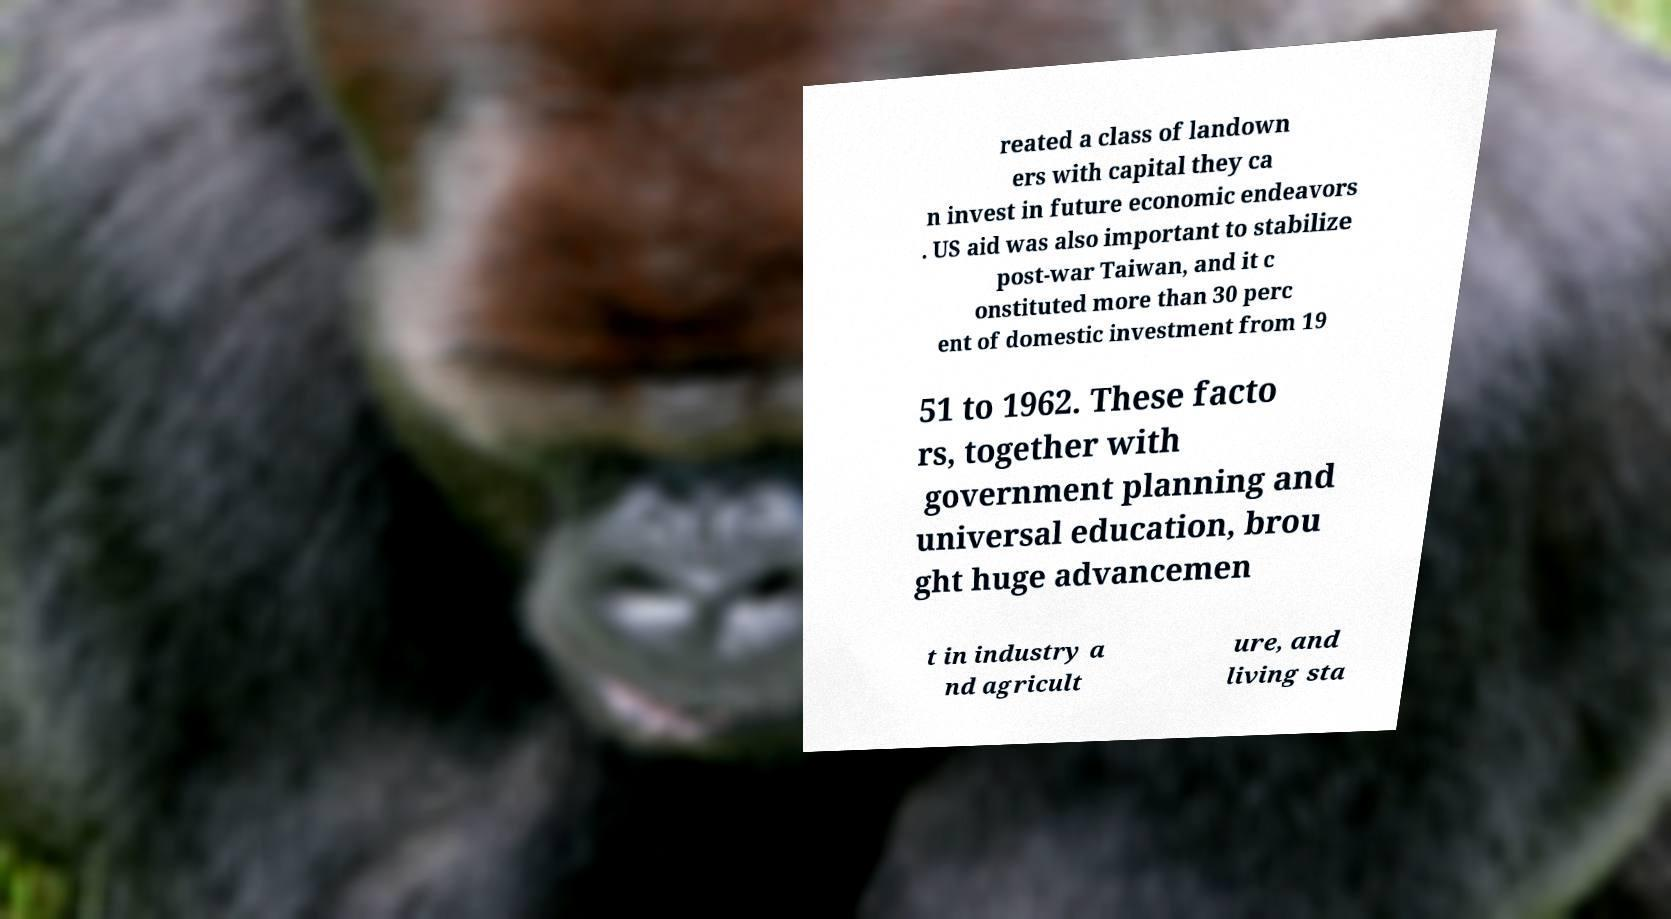For documentation purposes, I need the text within this image transcribed. Could you provide that? reated a class of landown ers with capital they ca n invest in future economic endeavors . US aid was also important to stabilize post-war Taiwan, and it c onstituted more than 30 perc ent of domestic investment from 19 51 to 1962. These facto rs, together with government planning and universal education, brou ght huge advancemen t in industry a nd agricult ure, and living sta 